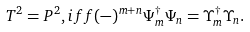Convert formula to latex. <formula><loc_0><loc_0><loc_500><loc_500>T ^ { 2 } = P ^ { 2 } , i f f ( - ) ^ { m + n } \Psi ^ { \dagger } _ { m } \Psi _ { n } = \Upsilon ^ { \dagger } _ { m } \Upsilon _ { n } .</formula> 